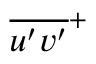<formula> <loc_0><loc_0><loc_500><loc_500>\overline { { u ^ { \prime } v ^ { \prime } } } ^ { + }</formula> 